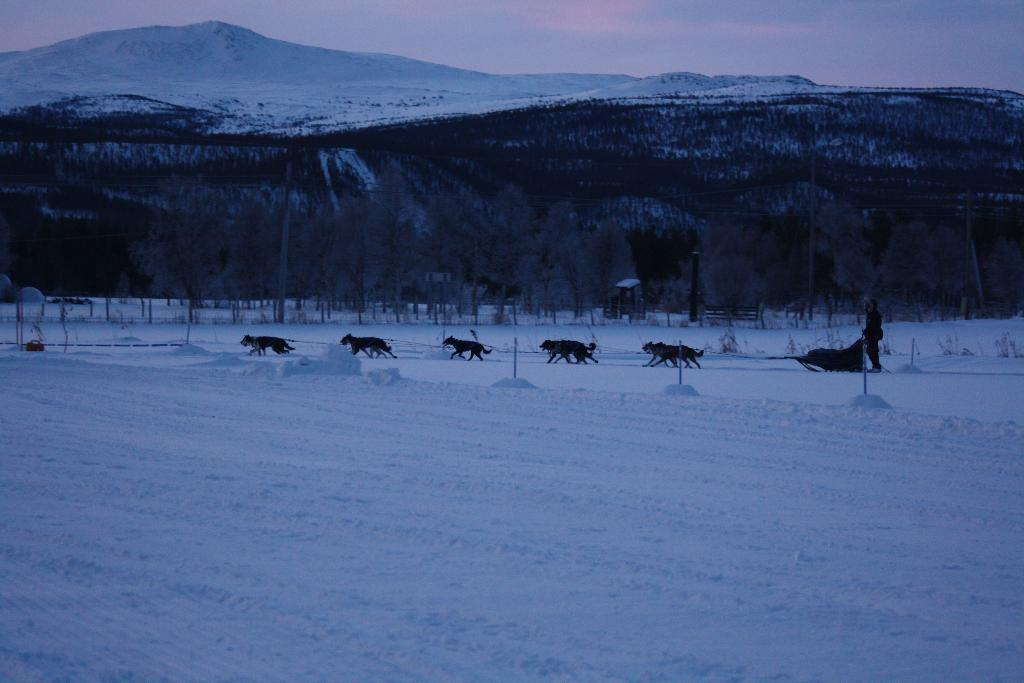What type of animals can be seen in the image? There are animals in the image. What are the animals doing in the image? The animals are walking on the snow. Can you describe the person on the right side of the image? There is a person on the right side of the image. What kind of terrain is visible in the image? There is a hill in the image, and many trees are present. What is visible at the top of the image? The sky is visible at the top of the image. What type of transport is being used by the minister in the image? There is no minister or transport present in the image. Can you tell me how many people are in the group walking on the snow? There is no group mentioned in the image; only individual animals are walking on the snow. 